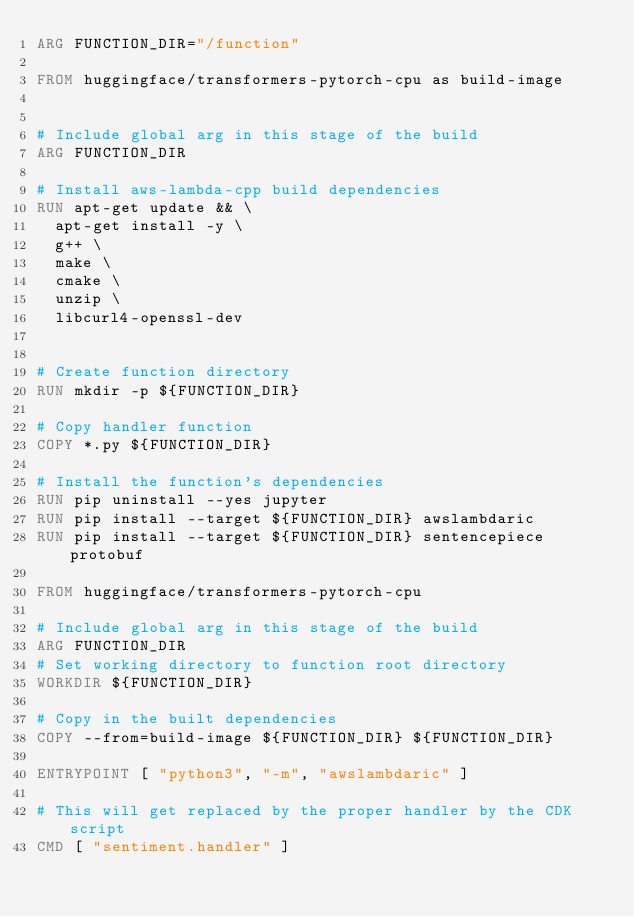Convert code to text. <code><loc_0><loc_0><loc_500><loc_500><_Dockerfile_>ARG FUNCTION_DIR="/function"

FROM huggingface/transformers-pytorch-cpu as build-image


# Include global arg in this stage of the build
ARG FUNCTION_DIR

# Install aws-lambda-cpp build dependencies
RUN apt-get update && \
  apt-get install -y \
  g++ \
  make \
  cmake \
  unzip \
  libcurl4-openssl-dev


# Create function directory
RUN mkdir -p ${FUNCTION_DIR}

# Copy handler function
COPY *.py ${FUNCTION_DIR}

# Install the function's dependencies
RUN pip uninstall --yes jupyter
RUN pip install --target ${FUNCTION_DIR} awslambdaric
RUN pip install --target ${FUNCTION_DIR} sentencepiece protobuf

FROM huggingface/transformers-pytorch-cpu

# Include global arg in this stage of the build
ARG FUNCTION_DIR
# Set working directory to function root directory
WORKDIR ${FUNCTION_DIR}

# Copy in the built dependencies
COPY --from=build-image ${FUNCTION_DIR} ${FUNCTION_DIR}

ENTRYPOINT [ "python3", "-m", "awslambdaric" ]

# This will get replaced by the proper handler by the CDK script
CMD [ "sentiment.handler" ]
</code> 